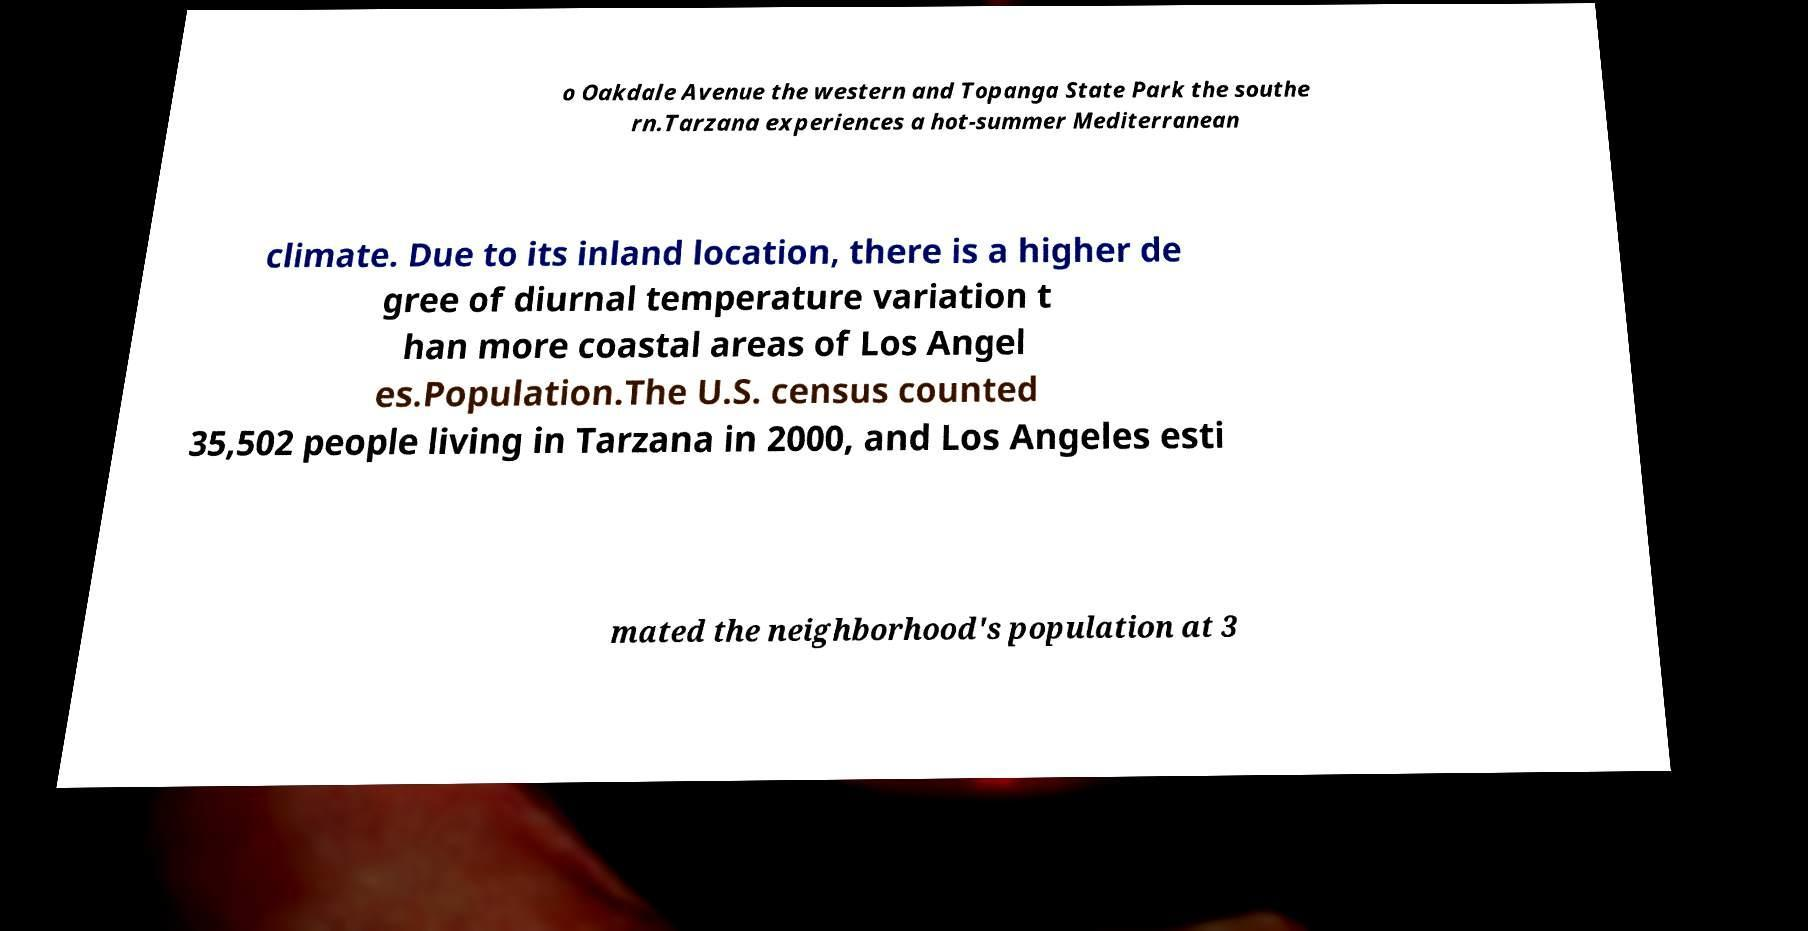I need the written content from this picture converted into text. Can you do that? o Oakdale Avenue the western and Topanga State Park the southe rn.Tarzana experiences a hot-summer Mediterranean climate. Due to its inland location, there is a higher de gree of diurnal temperature variation t han more coastal areas of Los Angel es.Population.The U.S. census counted 35,502 people living in Tarzana in 2000, and Los Angeles esti mated the neighborhood's population at 3 